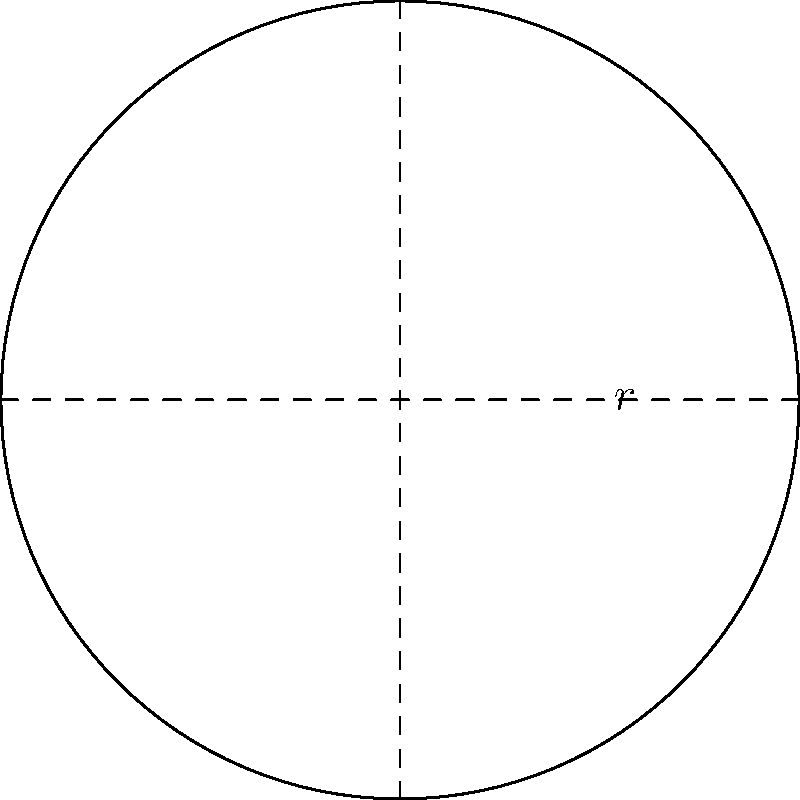As a busy professional who enjoys quick and easy recipes, you're preparing to bake a circular dish. The recipe calls for a baking dish with a radius of 5 inches. Using polar integration, calculate the surface area of the circular base of the dish. Round your answer to the nearest square inch. Let's approach this step-by-step:

1) The formula for the surface area of a circle using polar coordinates is:

   $$A = \int_0^{2\pi} \int_0^r r \, dr \, d\theta$$

   Where $r$ is the radius of the circle.

2) In this case, $r = 5$ inches.

3) Let's solve the inner integral first:

   $$\int_0^r r \, dr = \frac{r^2}{2}|_0^5 = \frac{5^2}{2} = \frac{25}{2}$$

4) Now our equation looks like:

   $$A = \int_0^{2\pi} \frac{25}{2} \, d\theta$$

5) Solving this:

   $$A = \frac{25}{2} \theta |_0^{2\pi} = \frac{25}{2} (2\pi - 0) = 25\pi$$

6) $25\pi \approx 78.54$ square inches

7) Rounding to the nearest square inch:

   $A \approx 79$ square inches
Answer: 79 square inches 